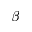<formula> <loc_0><loc_0><loc_500><loc_500>\beta</formula> 